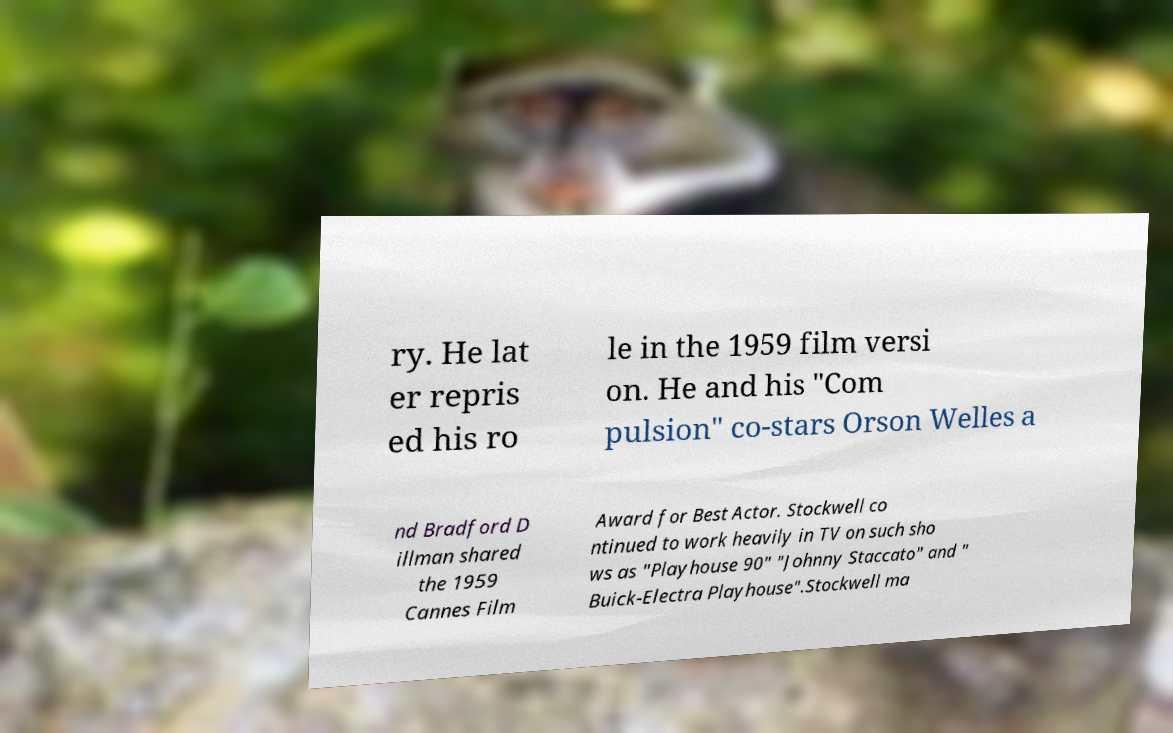Can you accurately transcribe the text from the provided image for me? ry. He lat er repris ed his ro le in the 1959 film versi on. He and his "Com pulsion" co-stars Orson Welles a nd Bradford D illman shared the 1959 Cannes Film Award for Best Actor. Stockwell co ntinued to work heavily in TV on such sho ws as "Playhouse 90" "Johnny Staccato" and " Buick-Electra Playhouse".Stockwell ma 